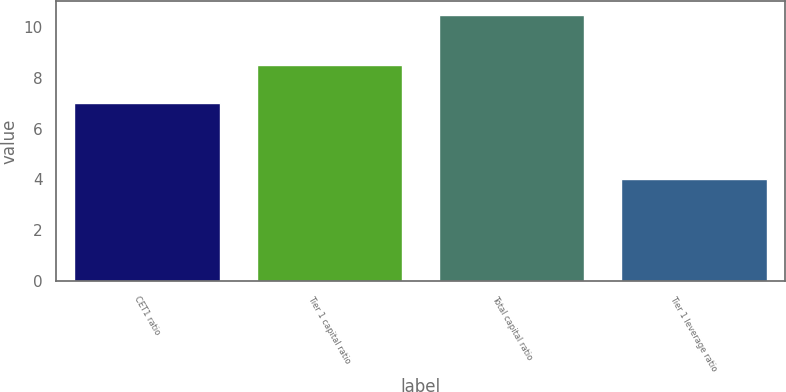Convert chart. <chart><loc_0><loc_0><loc_500><loc_500><bar_chart><fcel>CET1 ratio<fcel>Tier 1 capital ratio<fcel>Total capital ratio<fcel>Tier 1 leverage ratio<nl><fcel>7<fcel>8.5<fcel>10.5<fcel>4<nl></chart> 